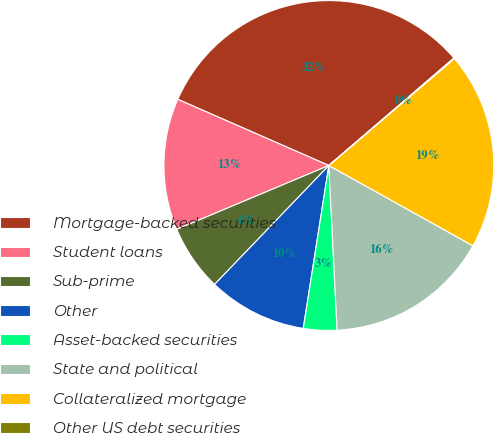Convert chart to OTSL. <chart><loc_0><loc_0><loc_500><loc_500><pie_chart><fcel>Mortgage-backed securities<fcel>Student loans<fcel>Sub-prime<fcel>Other<fcel>Asset-backed securities<fcel>State and political<fcel>Collateralized mortgage<fcel>Other US debt securities<nl><fcel>32.13%<fcel>12.9%<fcel>6.49%<fcel>9.7%<fcel>3.28%<fcel>16.11%<fcel>19.31%<fcel>0.08%<nl></chart> 